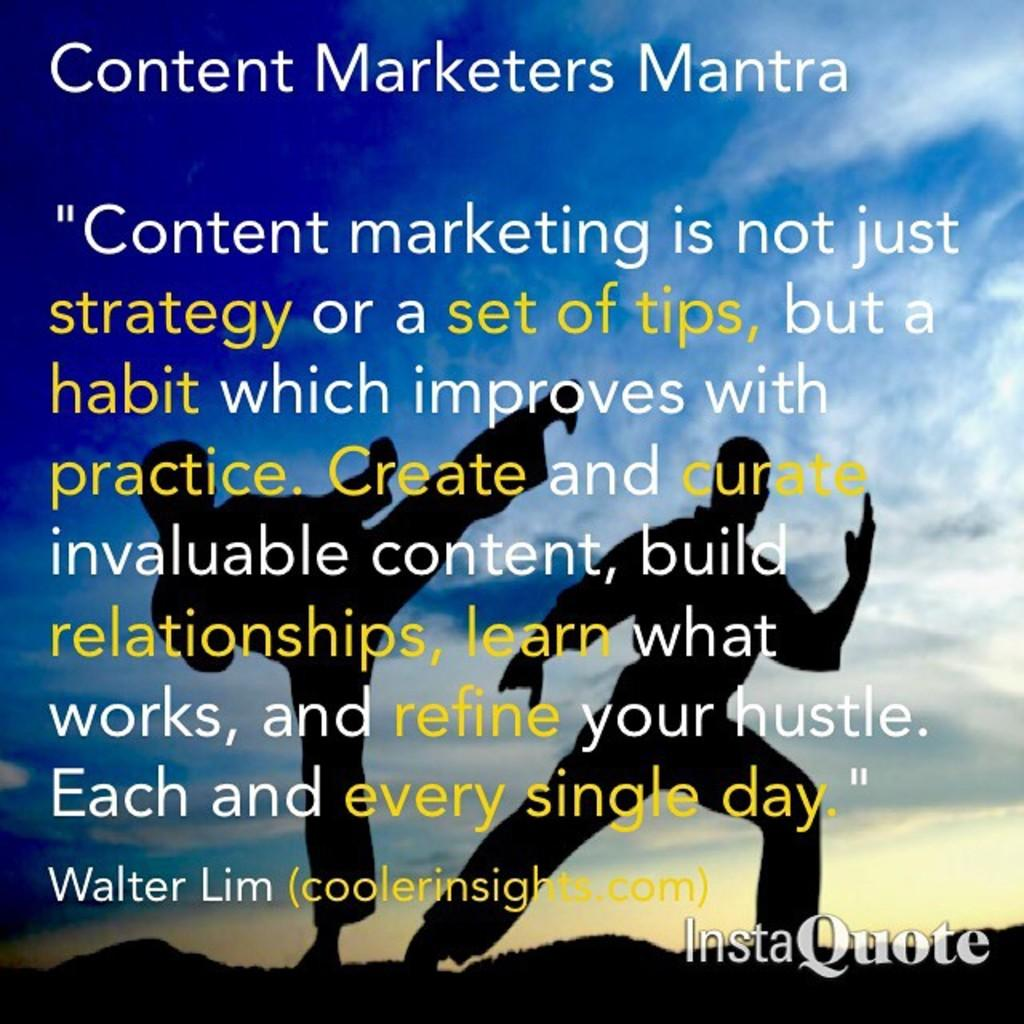<image>
Summarize the visual content of the image. A slide showing information about the content marketers mantra 